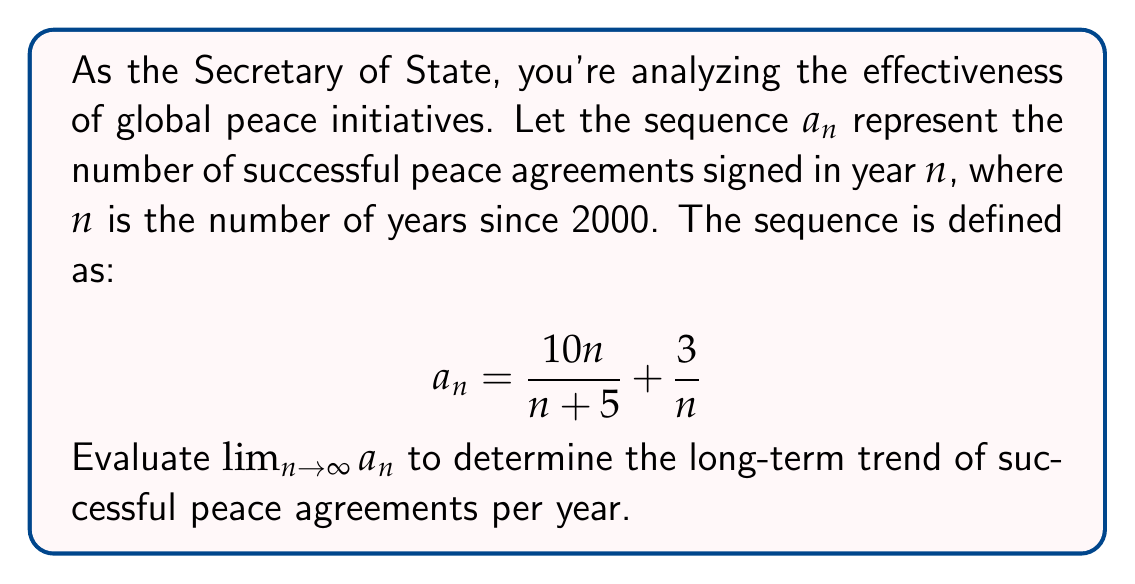Show me your answer to this math problem. To evaluate this limit, we'll follow these steps:

1) First, let's separate the sequence into two parts:
   $$\lim_{n \to \infty} a_n = \lim_{n \to \infty} \left(\frac{10n}{n+5} + \frac{3}{n}\right)$$

2) We can evaluate each part separately:
   $$\lim_{n \to \infty} a_n = \lim_{n \to \infty} \frac{10n}{n+5} + \lim_{n \to \infty} \frac{3}{n}$$

3) For the first part, $\frac{10n}{n+5}$:
   - Both numerator and denominator approach infinity as $n \to \infty$
   - We can divide both top and bottom by $n$:
     $$\lim_{n \to \infty} \frac{10n}{n+5} = \lim_{n \to \infty} \frac{10}{1+\frac{5}{n}} = 10$$

4) For the second part, $\frac{3}{n}$:
   $$\lim_{n \to \infty} \frac{3}{n} = 0$$

5) Combining the results:
   $$\lim_{n \to \infty} a_n = 10 + 0 = 10$$
Answer: 10 